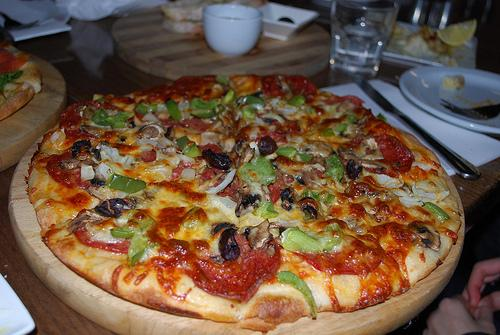Can you tell me about some of the objects in the image, one being a main food item? The image contains a delicious looking pizza with various toppings such as pepperoni, black olives, and green peppers, placed on a wooden serving board. Analyze the image's sentiment based on its contents and the overall scene. The image portrays a positive and inviting atmosphere with a delicious and colorful pizza being the center of attention, surrounded by utensils and items suggesting a pleasant mealtime gathering. Is there a blue cup at the top-left corner of the image? There is a white cup mentioned in the image but not a blue cup. The color is misleading. Are there three forks in the bottom right corner of the image? There is only one fork mentioned (tip of a fork) in the image, not three forks. The number is misleading. Can you spot a square pizza in the center of the image? There is a round pizza mentioned in the image, not a square pizza. The shape is misleading. Is the pizza topped with strawberries and whipped cream? The pizza is mentioned with various toppings like pepperoni, olives, and peppers, but not with strawberries and whipped cream. The toppings are misleading. Can you find a golden knife with intricate engravings next to the pizza? No, it's not mentioned in the image. Do you see a chocolate cake on the table with food and plates? There is no mention of a chocolate cake in the image. The object is misleading. 